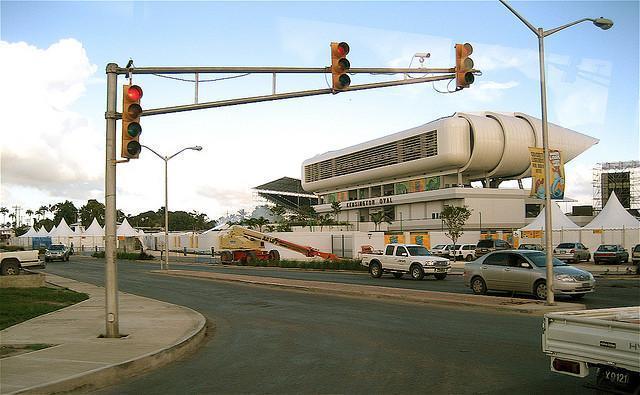How many trucks are there?
Give a very brief answer. 3. How many trucks can you see?
Give a very brief answer. 3. How many cars are in the photo?
Give a very brief answer. 1. How many other animals besides the giraffe are in the picture?
Give a very brief answer. 0. 